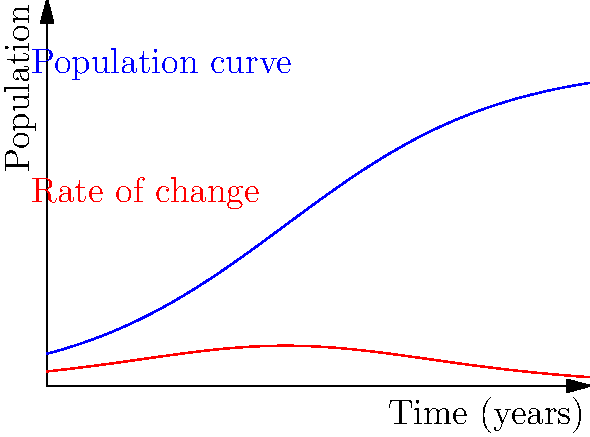Given the population growth curve (blue) and its rate of change (red) for a certain species over time, determine the time at which the population is growing most rapidly. Explain your reasoning using calculus concepts. To find when the population is growing most rapidly, we need to analyze the rate of change curve (red):

1) The rate of change curve represents the first derivative of the population curve.

2) The maximum point on the rate of change curve indicates the time when the population is growing fastest.

3) To find this maximum, we need to find where the derivative of the rate of change (second derivative of population) equals zero.

4) From the graph, we can see that the rate of change curve peaks at around $t=4$ years.

5) This point corresponds to the inflection point on the population curve, where it changes from concave up to concave down.

6) Mathematically, if $P(t)$ represents the population function:
   $$\frac{d^2P}{dt^2}(4) = 0$$

7) This is consistent with the logistic growth model, where the maximum growth rate occurs at the inflection point, halfway to the carrying capacity.
Answer: 4 years 